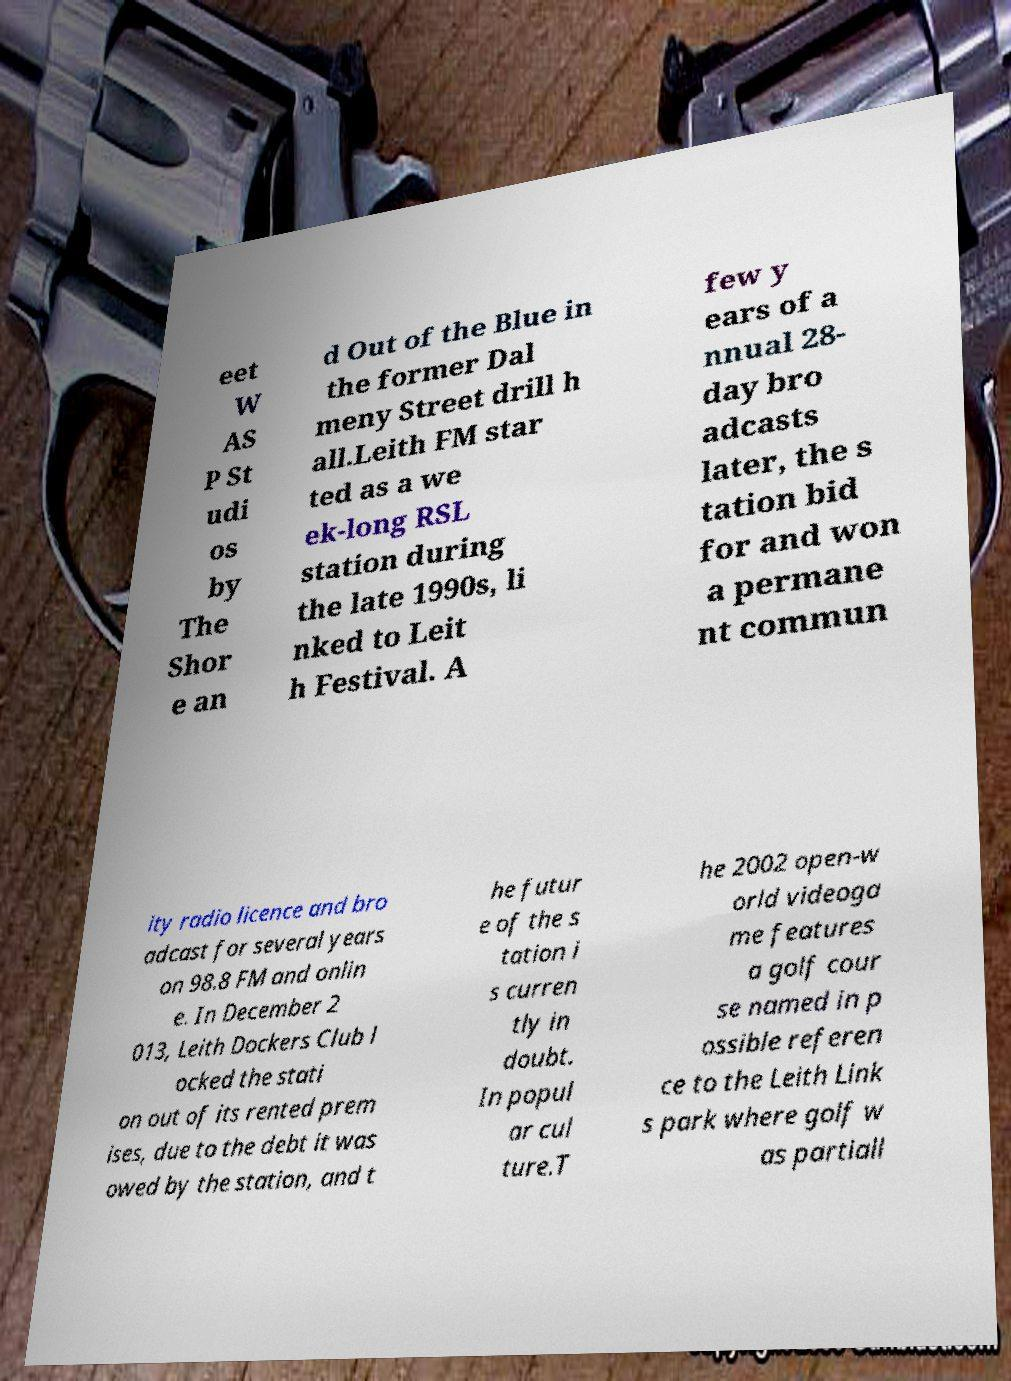I need the written content from this picture converted into text. Can you do that? eet W AS P St udi os by The Shor e an d Out of the Blue in the former Dal meny Street drill h all.Leith FM star ted as a we ek-long RSL station during the late 1990s, li nked to Leit h Festival. A few y ears of a nnual 28- day bro adcasts later, the s tation bid for and won a permane nt commun ity radio licence and bro adcast for several years on 98.8 FM and onlin e. In December 2 013, Leith Dockers Club l ocked the stati on out of its rented prem ises, due to the debt it was owed by the station, and t he futur e of the s tation i s curren tly in doubt. In popul ar cul ture.T he 2002 open-w orld videoga me features a golf cour se named in p ossible referen ce to the Leith Link s park where golf w as partiall 